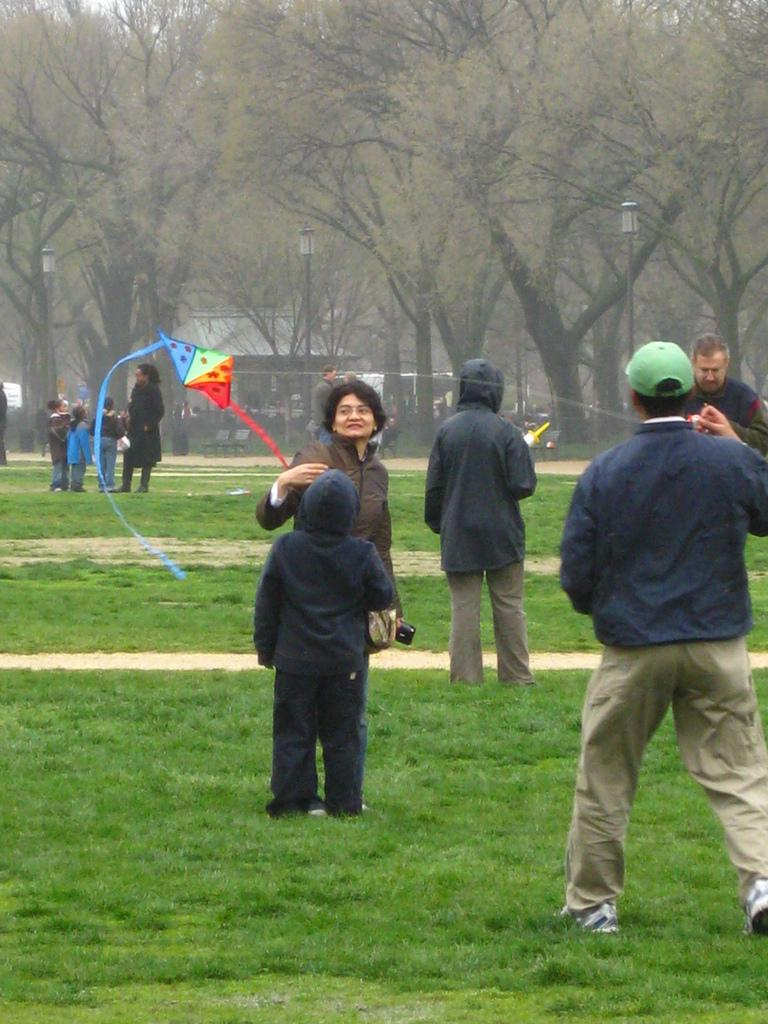Question: where are the people?
Choices:
A. In Paris.
B. At the park.
C. In London.
D. At the beach.
Answer with the letter. Answer: B Question: what are the people wearing?
Choices:
A. Jackets.
B. Swimsuits.
C. Workout clothes.
D. Yoga pants and tank tops.
Answer with the letter. Answer: A Question: what is the man in the green hat flying?
Choices:
A. A kite.
B. A remote control airplane.
C. A remote control helicopter.
D. A small plane.
Answer with the letter. Answer: A Question: why is the man flying a kite?
Choices:
A. It's windy.
B. To have fun.
C. He is bored.
D. Something to do.
Answer with the letter. Answer: B Question: what color is the grass?
Choices:
A. It is yellow.
B. It is brown.
C. It is green.
D. It is gray.
Answer with the letter. Answer: C Question: where are the people?
Choices:
A. A zoo.
B. At a park.
C. A concert.
D. A beach.
Answer with the letter. Answer: B Question: what color is the man's hat?
Choices:
A. Red.
B. Blue.
C. Green.
D. Yellow.
Answer with the letter. Answer: C Question: why can you see three people's backs?
Choices:
A. They are turned away.
B. They are walking away.
C. They are walking in circles.
D. They are running away.
Answer with the letter. Answer: A Question: what is green and healthy?
Choices:
A. Grass.
B. Leaves on the trees.
C. Bushes.
D. Flower stems.
Answer with the letter. Answer: A Question: why are they wearing jackets?
Choices:
A. It is snowing.
B. It's cool.
C. It is windy.
D. It is raining.
Answer with the letter. Answer: B Question: where are the people?
Choices:
A. At a park.
B. At a zoo.
C. At a mall.
D. At an office.
Answer with the letter. Answer: A Question: what are the adult and child playing with?
Choices:
A. A balloon.
B. A toy.
C. A kite.
D. A race car.
Answer with the letter. Answer: C 